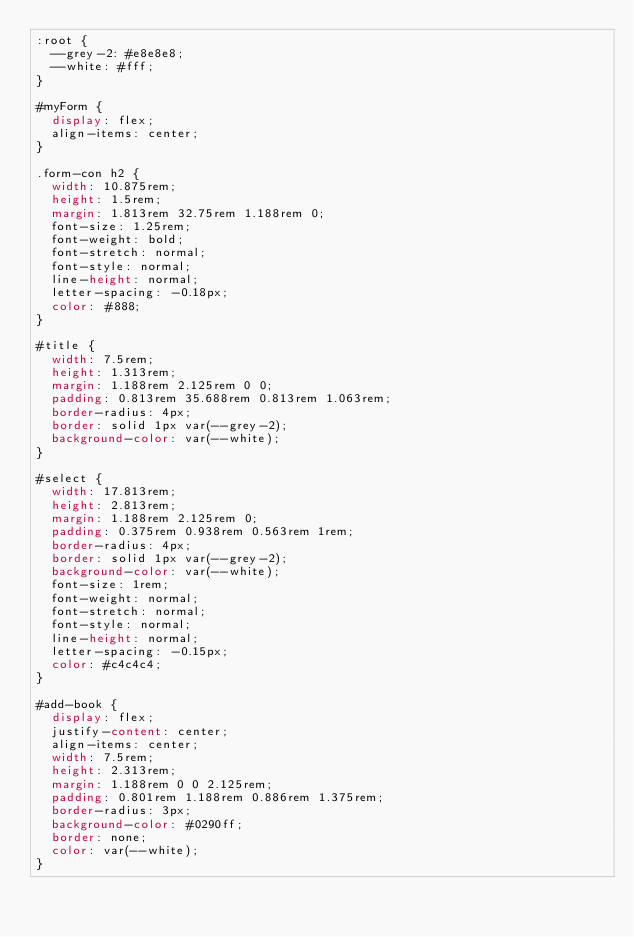<code> <loc_0><loc_0><loc_500><loc_500><_CSS_>:root {
  --grey-2: #e8e8e8;
  --white: #fff;
}

#myForm {
  display: flex;
  align-items: center;
}

.form-con h2 {
  width: 10.875rem;
  height: 1.5rem;
  margin: 1.813rem 32.75rem 1.188rem 0;
  font-size: 1.25rem;
  font-weight: bold;
  font-stretch: normal;
  font-style: normal;
  line-height: normal;
  letter-spacing: -0.18px;
  color: #888;
}

#title {
  width: 7.5rem;
  height: 1.313rem;
  margin: 1.188rem 2.125rem 0 0;
  padding: 0.813rem 35.688rem 0.813rem 1.063rem;
  border-radius: 4px;
  border: solid 1px var(--grey-2);
  background-color: var(--white);
}

#select {
  width: 17.813rem;
  height: 2.813rem;
  margin: 1.188rem 2.125rem 0;
  padding: 0.375rem 0.938rem 0.563rem 1rem;
  border-radius: 4px;
  border: solid 1px var(--grey-2);
  background-color: var(--white);
  font-size: 1rem;
  font-weight: normal;
  font-stretch: normal;
  font-style: normal;
  line-height: normal;
  letter-spacing: -0.15px;
  color: #c4c4c4;
}

#add-book {
  display: flex;
  justify-content: center;
  align-items: center;
  width: 7.5rem;
  height: 2.313rem;
  margin: 1.188rem 0 0 2.125rem;
  padding: 0.801rem 1.188rem 0.886rem 1.375rem;
  border-radius: 3px;
  background-color: #0290ff;
  border: none;
  color: var(--white);
}
</code> 